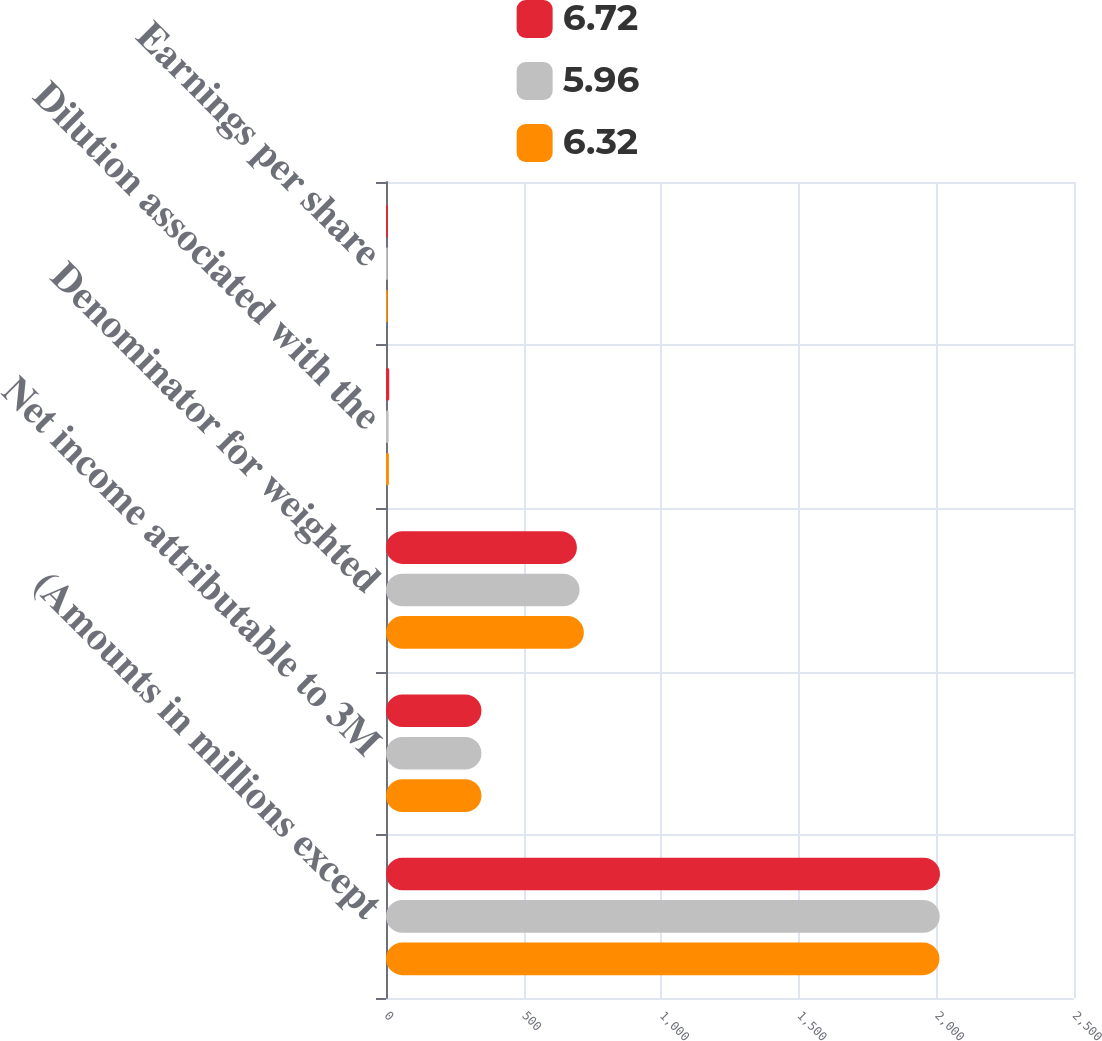<chart> <loc_0><loc_0><loc_500><loc_500><stacked_bar_chart><ecel><fcel>(Amounts in millions except<fcel>Net income attributable to 3M<fcel>Denominator for weighted<fcel>Dilution associated with the<fcel>Earnings per share<nl><fcel>6.72<fcel>2013<fcel>346.8<fcel>693.6<fcel>11.7<fcel>6.72<nl><fcel>5.96<fcel>2012<fcel>346.8<fcel>703.3<fcel>9.4<fcel>6.32<nl><fcel>6.32<fcel>2011<fcel>346.8<fcel>719<fcel>10.5<fcel>5.96<nl></chart> 